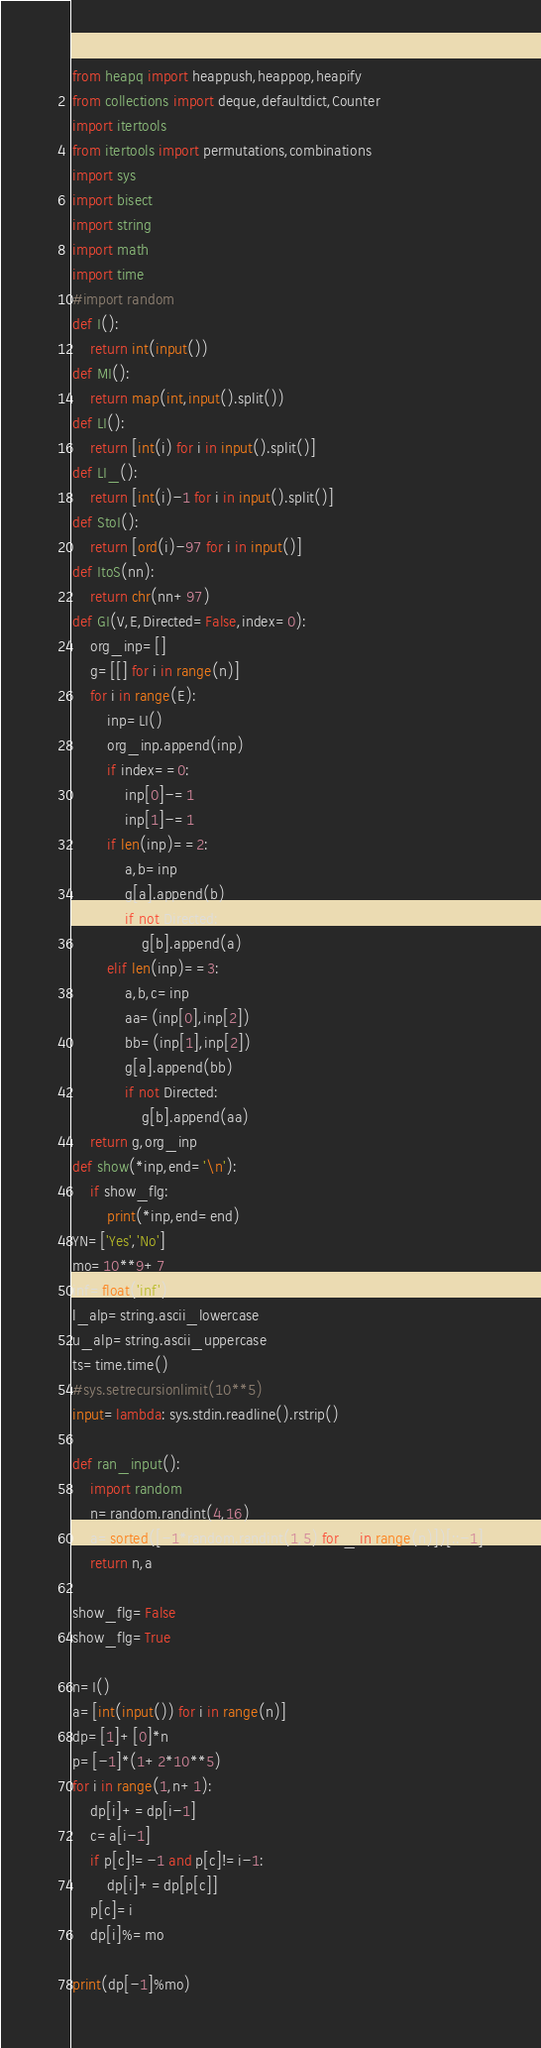Convert code to text. <code><loc_0><loc_0><loc_500><loc_500><_Python_>from heapq import heappush,heappop,heapify
from collections import deque,defaultdict,Counter
import itertools
from itertools import permutations,combinations
import sys
import bisect
import string
import math
import time
#import random
def I():
    return int(input())
def MI():
    return map(int,input().split())
def LI():
    return [int(i) for i in input().split()]
def LI_():
    return [int(i)-1 for i in input().split()]
def StoI():
    return [ord(i)-97 for i in input()]
def ItoS(nn):
    return chr(nn+97)
def GI(V,E,Directed=False,index=0):
    org_inp=[]
    g=[[] for i in range(n)]
    for i in range(E):
        inp=LI()
        org_inp.append(inp)
        if index==0:
            inp[0]-=1
            inp[1]-=1
        if len(inp)==2:
            a,b=inp
            g[a].append(b)
            if not Directed:
                g[b].append(a)
        elif len(inp)==3:
            a,b,c=inp
            aa=(inp[0],inp[2])
            bb=(inp[1],inp[2])
            g[a].append(bb)
            if not Directed:
                g[b].append(aa)
    return g,org_inp
def show(*inp,end='\n'):
    if show_flg:
        print(*inp,end=end)
YN=['Yes','No']
mo=10**9+7
inf=float('inf')
l_alp=string.ascii_lowercase
u_alp=string.ascii_uppercase
ts=time.time()
#sys.setrecursionlimit(10**5)
input=lambda: sys.stdin.readline().rstrip()

def ran_input():
    import random
    n=random.randint(4,16)
    a=sorted([-1*random.randint(1,5) for _ in range(n)])[::-1]
    return n,a

show_flg=False
show_flg=True

n=I()
a=[int(input()) for i in range(n)]
dp=[1]+[0]*n
p=[-1]*(1+2*10**5)
for i in range(1,n+1):
    dp[i]+=dp[i-1]
    c=a[i-1]
    if p[c]!=-1 and p[c]!=i-1:
        dp[i]+=dp[p[c]]
    p[c]=i
    dp[i]%=mo

print(dp[-1]%mo)

</code> 